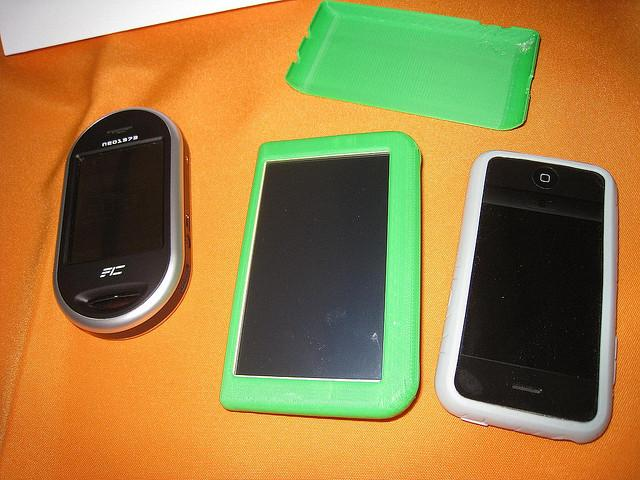What is all the way to the right?

Choices:
A) elephant
B) baby
C) phone
D) tiger phone 